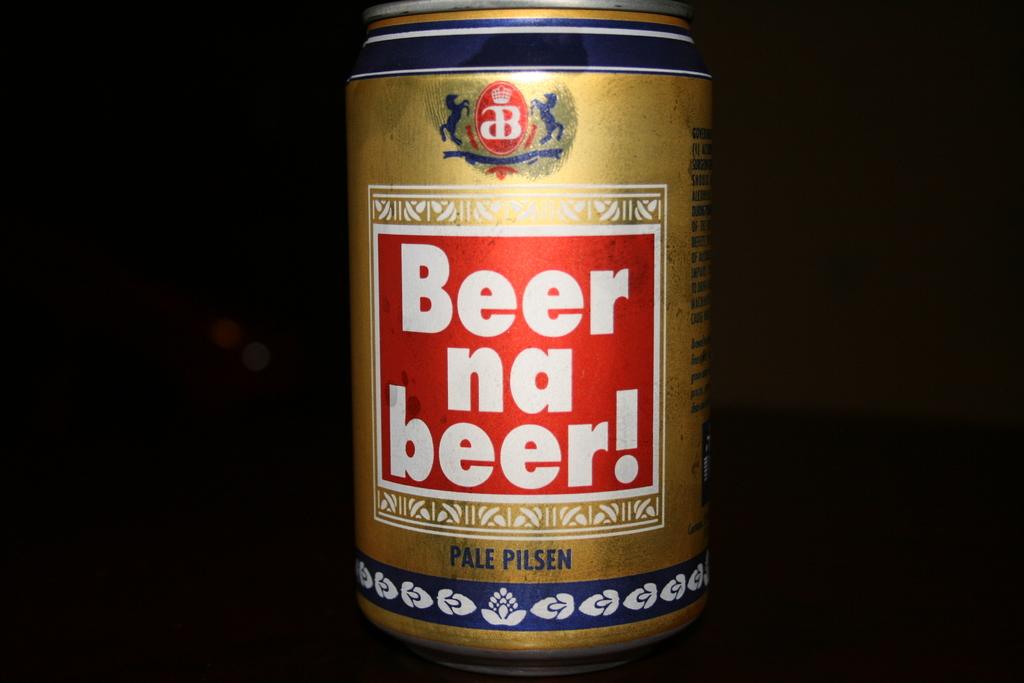What type of alcohol is in the can?
Your response must be concise. Beer. 